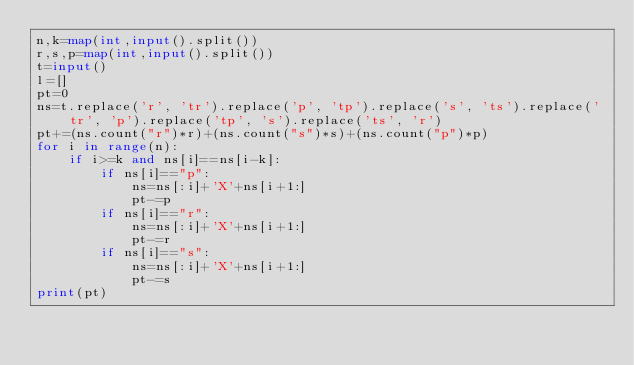Convert code to text. <code><loc_0><loc_0><loc_500><loc_500><_Python_>n,k=map(int,input().split())
r,s,p=map(int,input().split())
t=input()
l=[]
pt=0
ns=t.replace('r', 'tr').replace('p', 'tp').replace('s', 'ts').replace('tr', 'p').replace('tp', 's').replace('ts', 'r')
pt+=(ns.count("r")*r)+(ns.count("s")*s)+(ns.count("p")*p)
for i in range(n):
    if i>=k and ns[i]==ns[i-k]:
        if ns[i]=="p":
            ns=ns[:i]+'X'+ns[i+1:]
            pt-=p
        if ns[i]=="r":
            ns=ns[:i]+'X'+ns[i+1:]
            pt-=r
        if ns[i]=="s":
            ns=ns[:i]+'X'+ns[i+1:]
            pt-=s
print(pt)
</code> 